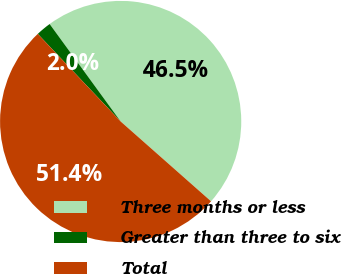<chart> <loc_0><loc_0><loc_500><loc_500><pie_chart><fcel>Three months or less<fcel>Greater than three to six<fcel>Total<nl><fcel>46.53%<fcel>2.04%<fcel>51.42%<nl></chart> 